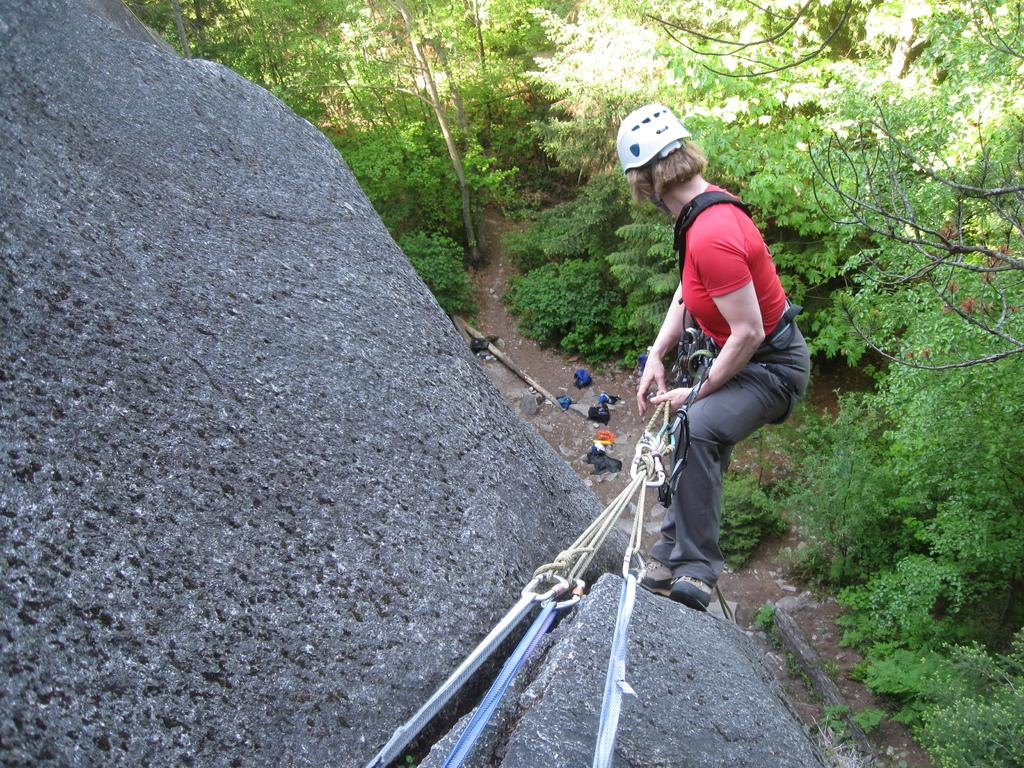What type of natural elements can be seen in the image? There are trees and plants in the image. Can you describe the person in the image? There is a person in the image. What activity is the person engaged in? The person is climbing a rock hill. What type of shoes is the person wearing while climbing the snowy hill in the image? There is no snow or hill mentioned in the image, and no shoes are visible on the person. 